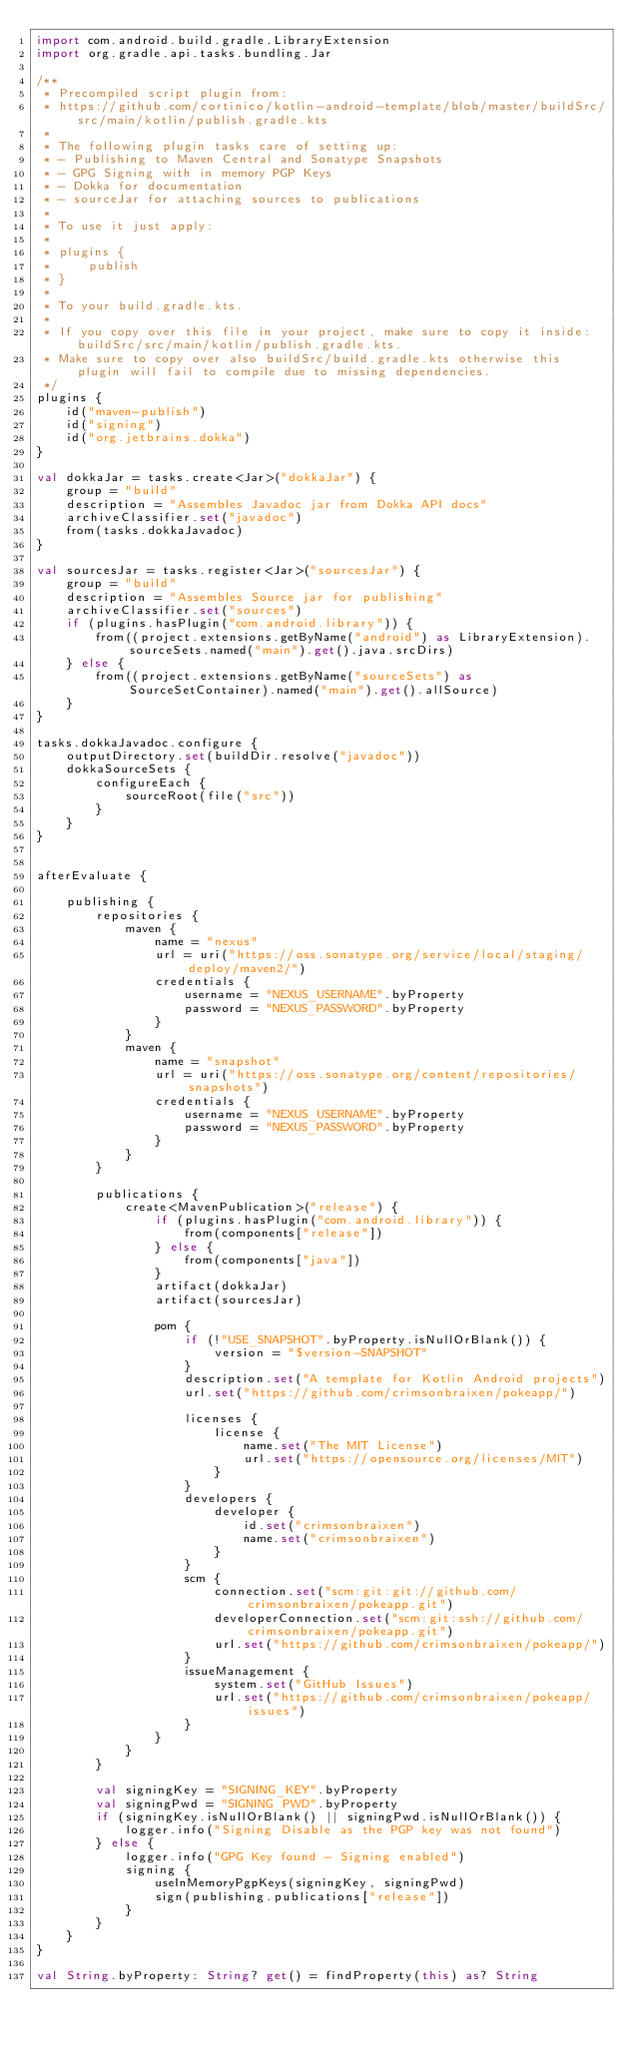Convert code to text. <code><loc_0><loc_0><loc_500><loc_500><_Kotlin_>import com.android.build.gradle.LibraryExtension
import org.gradle.api.tasks.bundling.Jar

/**
 * Precompiled script plugin from:
 * https://github.com/cortinico/kotlin-android-template/blob/master/buildSrc/src/main/kotlin/publish.gradle.kts
 *
 * The following plugin tasks care of setting up:
 * - Publishing to Maven Central and Sonatype Snapshots
 * - GPG Signing with in memory PGP Keys
 * - Dokka for documentation
 * - sourceJar for attaching sources to publications
 *
 * To use it just apply:
 *
 * plugins {
 *     publish
 * }
 *
 * To your build.gradle.kts.
 *
 * If you copy over this file in your project, make sure to copy it inside: buildSrc/src/main/kotlin/publish.gradle.kts.
 * Make sure to copy over also buildSrc/build.gradle.kts otherwise this plugin will fail to compile due to missing dependencies.
 */
plugins {
    id("maven-publish")
    id("signing")
    id("org.jetbrains.dokka")
}

val dokkaJar = tasks.create<Jar>("dokkaJar") {
    group = "build"
    description = "Assembles Javadoc jar from Dokka API docs"
    archiveClassifier.set("javadoc")
    from(tasks.dokkaJavadoc)
}

val sourcesJar = tasks.register<Jar>("sourcesJar") {
    group = "build"
    description = "Assembles Source jar for publishing"
    archiveClassifier.set("sources")
    if (plugins.hasPlugin("com.android.library")) {
        from((project.extensions.getByName("android") as LibraryExtension).sourceSets.named("main").get().java.srcDirs)
    } else {
        from((project.extensions.getByName("sourceSets") as SourceSetContainer).named("main").get().allSource)
    }
}

tasks.dokkaJavadoc.configure {
    outputDirectory.set(buildDir.resolve("javadoc"))
    dokkaSourceSets {
        configureEach {
            sourceRoot(file("src"))
        }
    }
}


afterEvaluate {

    publishing {
        repositories {
            maven {
                name = "nexus"
                url = uri("https://oss.sonatype.org/service/local/staging/deploy/maven2/")
                credentials {
                    username = "NEXUS_USERNAME".byProperty
                    password = "NEXUS_PASSWORD".byProperty
                }
            }
            maven {
                name = "snapshot"
                url = uri("https://oss.sonatype.org/content/repositories/snapshots")
                credentials {
                    username = "NEXUS_USERNAME".byProperty
                    password = "NEXUS_PASSWORD".byProperty
                }
            }
        }

        publications {
            create<MavenPublication>("release") {
                if (plugins.hasPlugin("com.android.library")) {
                    from(components["release"])
                } else {
                    from(components["java"])
                }
                artifact(dokkaJar)
                artifact(sourcesJar)

                pom {
                    if (!"USE_SNAPSHOT".byProperty.isNullOrBlank()) {
                        version = "$version-SNAPSHOT"
                    }
                    description.set("A template for Kotlin Android projects")
                    url.set("https://github.com/crimsonbraixen/pokeapp/")

                    licenses {
                        license {
                            name.set("The MIT License")
                            url.set("https://opensource.org/licenses/MIT")
                        }
                    }
                    developers {
                        developer {
                            id.set("crimsonbraixen")
                            name.set("crimsonbraixen")
                        }
                    }
                    scm {
                        connection.set("scm:git:git://github.com/crimsonbraixen/pokeapp.git")
                        developerConnection.set("scm:git:ssh://github.com/crimsonbraixen/pokeapp.git")
                        url.set("https://github.com/crimsonbraixen/pokeapp/")
                    }
                    issueManagement {
                        system.set("GitHub Issues")
                        url.set("https://github.com/crimsonbraixen/pokeapp/issues")
                    }
                }
            }
        }

        val signingKey = "SIGNING_KEY".byProperty
        val signingPwd = "SIGNING_PWD".byProperty
        if (signingKey.isNullOrBlank() || signingPwd.isNullOrBlank()) {
            logger.info("Signing Disable as the PGP key was not found")
        } else {
            logger.info("GPG Key found - Signing enabled")
            signing {
                useInMemoryPgpKeys(signingKey, signingPwd)
                sign(publishing.publications["release"])
            }
        }
    }
}

val String.byProperty: String? get() = findProperty(this) as? String
</code> 